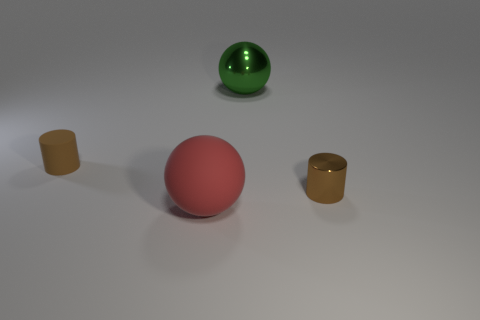Subtract all red balls. How many balls are left? 1 Add 2 metallic objects. How many objects exist? 6 Subtract all yellow spheres. Subtract all red cylinders. How many spheres are left? 2 Subtract all gray spheres. How many green cylinders are left? 0 Subtract all tiny matte cylinders. Subtract all metallic things. How many objects are left? 1 Add 1 large matte spheres. How many large matte spheres are left? 2 Add 4 large metal blocks. How many large metal blocks exist? 4 Subtract 0 cyan balls. How many objects are left? 4 Subtract 2 cylinders. How many cylinders are left? 0 